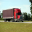The given image can contain some animals; they can be animals typically found in the wild or domesticated animals. The picture could also contain something that does not fit this description. Your job is to identify if the subject of the image is an animal or not. The image prominently displays a semi-truck, distinctly categorized as a non-living object used for transporting goods. It's noticeable that the truck takes center stage, with no animals or indications of wildlife present. This large vehicle, designed for long-distance haulage, starkly contrasts the organic forms of animals, emphasizing its mechanical and industrial nature. Therefore, it's definitive that the image does not feature any animals, focusing instead on a human-made invention crucial to modern transportation and commerce. 